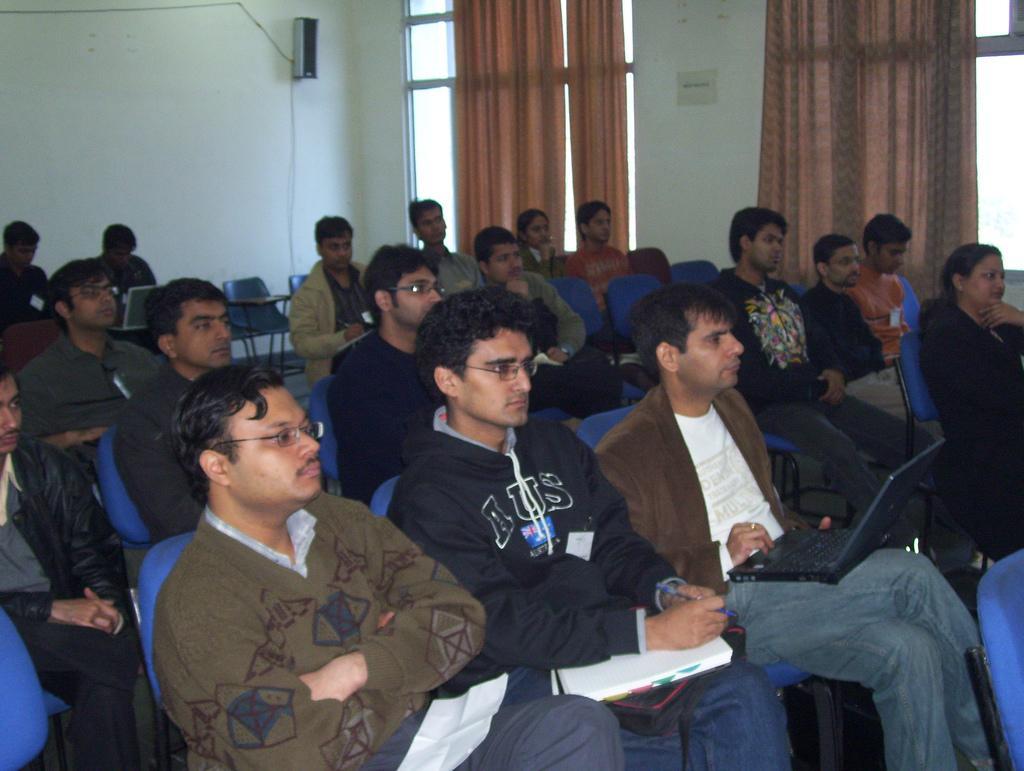Please provide a concise description of this image. In this picture we can see some people sitting on chairs, this man is holding a book, this man is holding a laptop, in the background there is a wall and a speaker, we can see curtains here. 